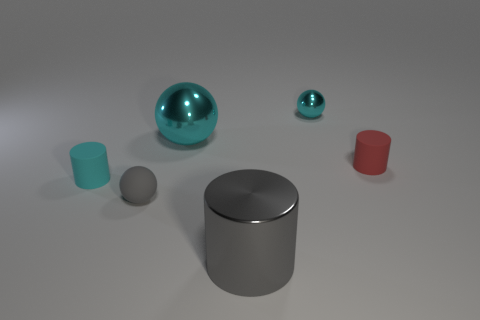Can you describe the largest object in the image? The largest object in the image is a gray, reflective cylinder with a matte finish on its flat top surface. What textures do the objects seem to have? The objects exhibit various textures. The spheres and cylinders appear to have a smooth surface, while the largest cylinder has a distinct matte finish on its top surface suggesting a non-glossy texture. 